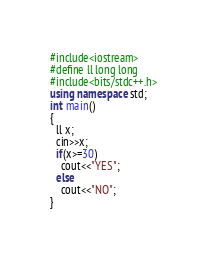<code> <loc_0><loc_0><loc_500><loc_500><_C++_>#include<iostream>
#define ll long long
#include<bits/stdc++.h>
using namespace std;
int main()
{
  ll x;
  cin>>x;
  if(x>=30)
    cout<<"YES";
  else
    cout<<"NO";
}</code> 